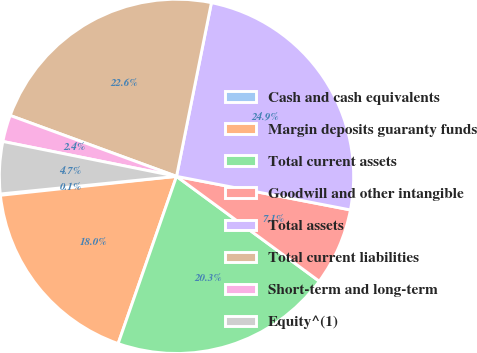<chart> <loc_0><loc_0><loc_500><loc_500><pie_chart><fcel>Cash and cash equivalents<fcel>Margin deposits guaranty funds<fcel>Total current assets<fcel>Goodwill and other intangible<fcel>Total assets<fcel>Total current liabilities<fcel>Short-term and long-term<fcel>Equity^(1)<nl><fcel>0.12%<fcel>17.95%<fcel>20.26%<fcel>7.05%<fcel>24.88%<fcel>22.57%<fcel>2.43%<fcel>4.74%<nl></chart> 